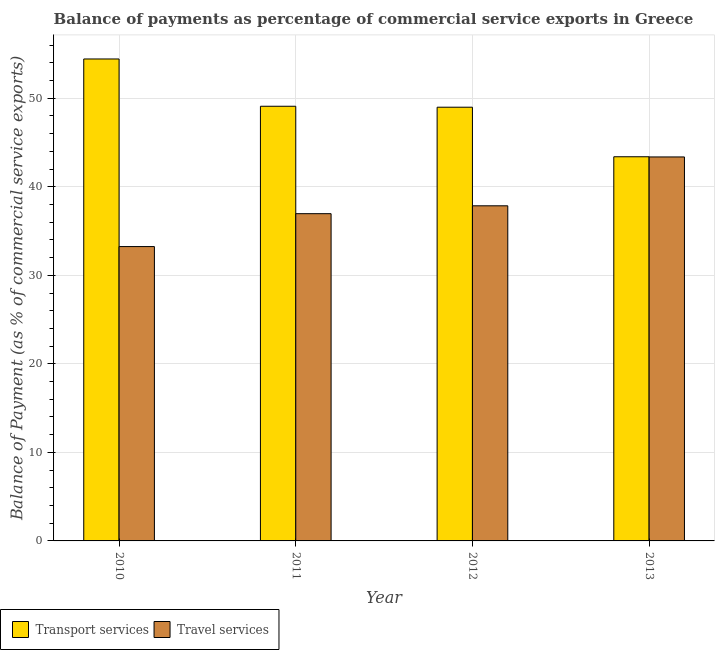Are the number of bars on each tick of the X-axis equal?
Your answer should be very brief. Yes. How many bars are there on the 1st tick from the left?
Make the answer very short. 2. What is the label of the 4th group of bars from the left?
Your response must be concise. 2013. In how many cases, is the number of bars for a given year not equal to the number of legend labels?
Ensure brevity in your answer.  0. What is the balance of payments of transport services in 2013?
Provide a short and direct response. 43.39. Across all years, what is the maximum balance of payments of travel services?
Provide a succinct answer. 43.37. Across all years, what is the minimum balance of payments of transport services?
Ensure brevity in your answer.  43.39. In which year was the balance of payments of transport services minimum?
Give a very brief answer. 2013. What is the total balance of payments of transport services in the graph?
Keep it short and to the point. 195.9. What is the difference between the balance of payments of transport services in 2012 and that in 2013?
Keep it short and to the point. 5.6. What is the difference between the balance of payments of travel services in 2013 and the balance of payments of transport services in 2011?
Provide a short and direct response. 6.41. What is the average balance of payments of travel services per year?
Make the answer very short. 37.86. In the year 2012, what is the difference between the balance of payments of travel services and balance of payments of transport services?
Your response must be concise. 0. In how many years, is the balance of payments of transport services greater than 52 %?
Provide a succinct answer. 1. What is the ratio of the balance of payments of transport services in 2011 to that in 2012?
Your answer should be compact. 1. Is the balance of payments of transport services in 2011 less than that in 2013?
Offer a very short reply. No. Is the difference between the balance of payments of travel services in 2010 and 2011 greater than the difference between the balance of payments of transport services in 2010 and 2011?
Your answer should be very brief. No. What is the difference between the highest and the second highest balance of payments of travel services?
Offer a very short reply. 5.52. What is the difference between the highest and the lowest balance of payments of transport services?
Keep it short and to the point. 11.05. Is the sum of the balance of payments of transport services in 2010 and 2012 greater than the maximum balance of payments of travel services across all years?
Your answer should be compact. Yes. What does the 2nd bar from the left in 2012 represents?
Ensure brevity in your answer.  Travel services. What does the 2nd bar from the right in 2012 represents?
Give a very brief answer. Transport services. How many bars are there?
Your response must be concise. 8. How many years are there in the graph?
Give a very brief answer. 4. Are the values on the major ticks of Y-axis written in scientific E-notation?
Offer a terse response. No. Does the graph contain grids?
Your answer should be compact. Yes. What is the title of the graph?
Provide a succinct answer. Balance of payments as percentage of commercial service exports in Greece. What is the label or title of the Y-axis?
Provide a short and direct response. Balance of Payment (as % of commercial service exports). What is the Balance of Payment (as % of commercial service exports) of Transport services in 2010?
Your answer should be compact. 54.43. What is the Balance of Payment (as % of commercial service exports) in Travel services in 2010?
Give a very brief answer. 33.25. What is the Balance of Payment (as % of commercial service exports) of Transport services in 2011?
Provide a succinct answer. 49.09. What is the Balance of Payment (as % of commercial service exports) of Travel services in 2011?
Give a very brief answer. 36.96. What is the Balance of Payment (as % of commercial service exports) of Transport services in 2012?
Provide a succinct answer. 48.99. What is the Balance of Payment (as % of commercial service exports) in Travel services in 2012?
Provide a short and direct response. 37.85. What is the Balance of Payment (as % of commercial service exports) of Transport services in 2013?
Ensure brevity in your answer.  43.39. What is the Balance of Payment (as % of commercial service exports) of Travel services in 2013?
Your answer should be compact. 43.37. Across all years, what is the maximum Balance of Payment (as % of commercial service exports) of Transport services?
Your response must be concise. 54.43. Across all years, what is the maximum Balance of Payment (as % of commercial service exports) in Travel services?
Keep it short and to the point. 43.37. Across all years, what is the minimum Balance of Payment (as % of commercial service exports) of Transport services?
Give a very brief answer. 43.39. Across all years, what is the minimum Balance of Payment (as % of commercial service exports) in Travel services?
Offer a terse response. 33.25. What is the total Balance of Payment (as % of commercial service exports) of Transport services in the graph?
Provide a succinct answer. 195.9. What is the total Balance of Payment (as % of commercial service exports) in Travel services in the graph?
Keep it short and to the point. 151.42. What is the difference between the Balance of Payment (as % of commercial service exports) in Transport services in 2010 and that in 2011?
Ensure brevity in your answer.  5.34. What is the difference between the Balance of Payment (as % of commercial service exports) in Travel services in 2010 and that in 2011?
Your answer should be very brief. -3.72. What is the difference between the Balance of Payment (as % of commercial service exports) of Transport services in 2010 and that in 2012?
Offer a very short reply. 5.45. What is the difference between the Balance of Payment (as % of commercial service exports) of Travel services in 2010 and that in 2012?
Your answer should be very brief. -4.61. What is the difference between the Balance of Payment (as % of commercial service exports) in Transport services in 2010 and that in 2013?
Keep it short and to the point. 11.05. What is the difference between the Balance of Payment (as % of commercial service exports) in Travel services in 2010 and that in 2013?
Your response must be concise. -10.12. What is the difference between the Balance of Payment (as % of commercial service exports) of Transport services in 2011 and that in 2012?
Keep it short and to the point. 0.11. What is the difference between the Balance of Payment (as % of commercial service exports) of Travel services in 2011 and that in 2012?
Give a very brief answer. -0.89. What is the difference between the Balance of Payment (as % of commercial service exports) in Transport services in 2011 and that in 2013?
Make the answer very short. 5.7. What is the difference between the Balance of Payment (as % of commercial service exports) of Travel services in 2011 and that in 2013?
Your answer should be compact. -6.41. What is the difference between the Balance of Payment (as % of commercial service exports) in Transport services in 2012 and that in 2013?
Keep it short and to the point. 5.6. What is the difference between the Balance of Payment (as % of commercial service exports) of Travel services in 2012 and that in 2013?
Your answer should be very brief. -5.52. What is the difference between the Balance of Payment (as % of commercial service exports) of Transport services in 2010 and the Balance of Payment (as % of commercial service exports) of Travel services in 2011?
Your answer should be compact. 17.47. What is the difference between the Balance of Payment (as % of commercial service exports) in Transport services in 2010 and the Balance of Payment (as % of commercial service exports) in Travel services in 2012?
Provide a short and direct response. 16.58. What is the difference between the Balance of Payment (as % of commercial service exports) in Transport services in 2010 and the Balance of Payment (as % of commercial service exports) in Travel services in 2013?
Ensure brevity in your answer.  11.07. What is the difference between the Balance of Payment (as % of commercial service exports) of Transport services in 2011 and the Balance of Payment (as % of commercial service exports) of Travel services in 2012?
Offer a terse response. 11.24. What is the difference between the Balance of Payment (as % of commercial service exports) in Transport services in 2011 and the Balance of Payment (as % of commercial service exports) in Travel services in 2013?
Ensure brevity in your answer.  5.72. What is the difference between the Balance of Payment (as % of commercial service exports) of Transport services in 2012 and the Balance of Payment (as % of commercial service exports) of Travel services in 2013?
Provide a short and direct response. 5.62. What is the average Balance of Payment (as % of commercial service exports) of Transport services per year?
Your answer should be very brief. 48.97. What is the average Balance of Payment (as % of commercial service exports) in Travel services per year?
Make the answer very short. 37.86. In the year 2010, what is the difference between the Balance of Payment (as % of commercial service exports) of Transport services and Balance of Payment (as % of commercial service exports) of Travel services?
Provide a short and direct response. 21.19. In the year 2011, what is the difference between the Balance of Payment (as % of commercial service exports) in Transport services and Balance of Payment (as % of commercial service exports) in Travel services?
Your answer should be compact. 12.13. In the year 2012, what is the difference between the Balance of Payment (as % of commercial service exports) of Transport services and Balance of Payment (as % of commercial service exports) of Travel services?
Offer a terse response. 11.14. In the year 2013, what is the difference between the Balance of Payment (as % of commercial service exports) of Transport services and Balance of Payment (as % of commercial service exports) of Travel services?
Your answer should be very brief. 0.02. What is the ratio of the Balance of Payment (as % of commercial service exports) of Transport services in 2010 to that in 2011?
Make the answer very short. 1.11. What is the ratio of the Balance of Payment (as % of commercial service exports) of Travel services in 2010 to that in 2011?
Keep it short and to the point. 0.9. What is the ratio of the Balance of Payment (as % of commercial service exports) of Transport services in 2010 to that in 2012?
Offer a very short reply. 1.11. What is the ratio of the Balance of Payment (as % of commercial service exports) in Travel services in 2010 to that in 2012?
Offer a terse response. 0.88. What is the ratio of the Balance of Payment (as % of commercial service exports) of Transport services in 2010 to that in 2013?
Your answer should be compact. 1.25. What is the ratio of the Balance of Payment (as % of commercial service exports) in Travel services in 2010 to that in 2013?
Offer a very short reply. 0.77. What is the ratio of the Balance of Payment (as % of commercial service exports) of Transport services in 2011 to that in 2012?
Provide a succinct answer. 1. What is the ratio of the Balance of Payment (as % of commercial service exports) in Travel services in 2011 to that in 2012?
Your response must be concise. 0.98. What is the ratio of the Balance of Payment (as % of commercial service exports) of Transport services in 2011 to that in 2013?
Offer a terse response. 1.13. What is the ratio of the Balance of Payment (as % of commercial service exports) in Travel services in 2011 to that in 2013?
Your answer should be compact. 0.85. What is the ratio of the Balance of Payment (as % of commercial service exports) of Transport services in 2012 to that in 2013?
Provide a short and direct response. 1.13. What is the ratio of the Balance of Payment (as % of commercial service exports) in Travel services in 2012 to that in 2013?
Offer a very short reply. 0.87. What is the difference between the highest and the second highest Balance of Payment (as % of commercial service exports) of Transport services?
Make the answer very short. 5.34. What is the difference between the highest and the second highest Balance of Payment (as % of commercial service exports) of Travel services?
Offer a very short reply. 5.52. What is the difference between the highest and the lowest Balance of Payment (as % of commercial service exports) in Transport services?
Give a very brief answer. 11.05. What is the difference between the highest and the lowest Balance of Payment (as % of commercial service exports) of Travel services?
Keep it short and to the point. 10.12. 